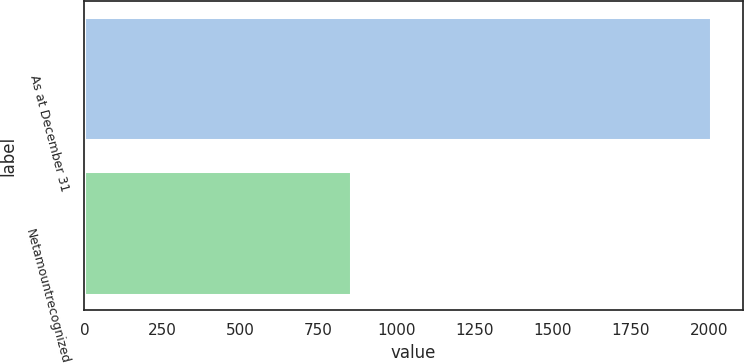Convert chart. <chart><loc_0><loc_0><loc_500><loc_500><bar_chart><fcel>As at December 31<fcel>Netamountrecognized<nl><fcel>2008<fcel>854<nl></chart> 